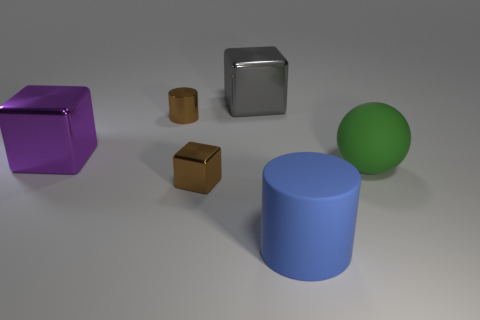What shapes can you identify in this image? In the image, there are several distinct shapes: a purple cube, a gold cylinder, a green sphere, a small brown cube, and a larger reflective silver cube. These shapes provide a variety of geometric forms and different surfaces reflecting the light. 